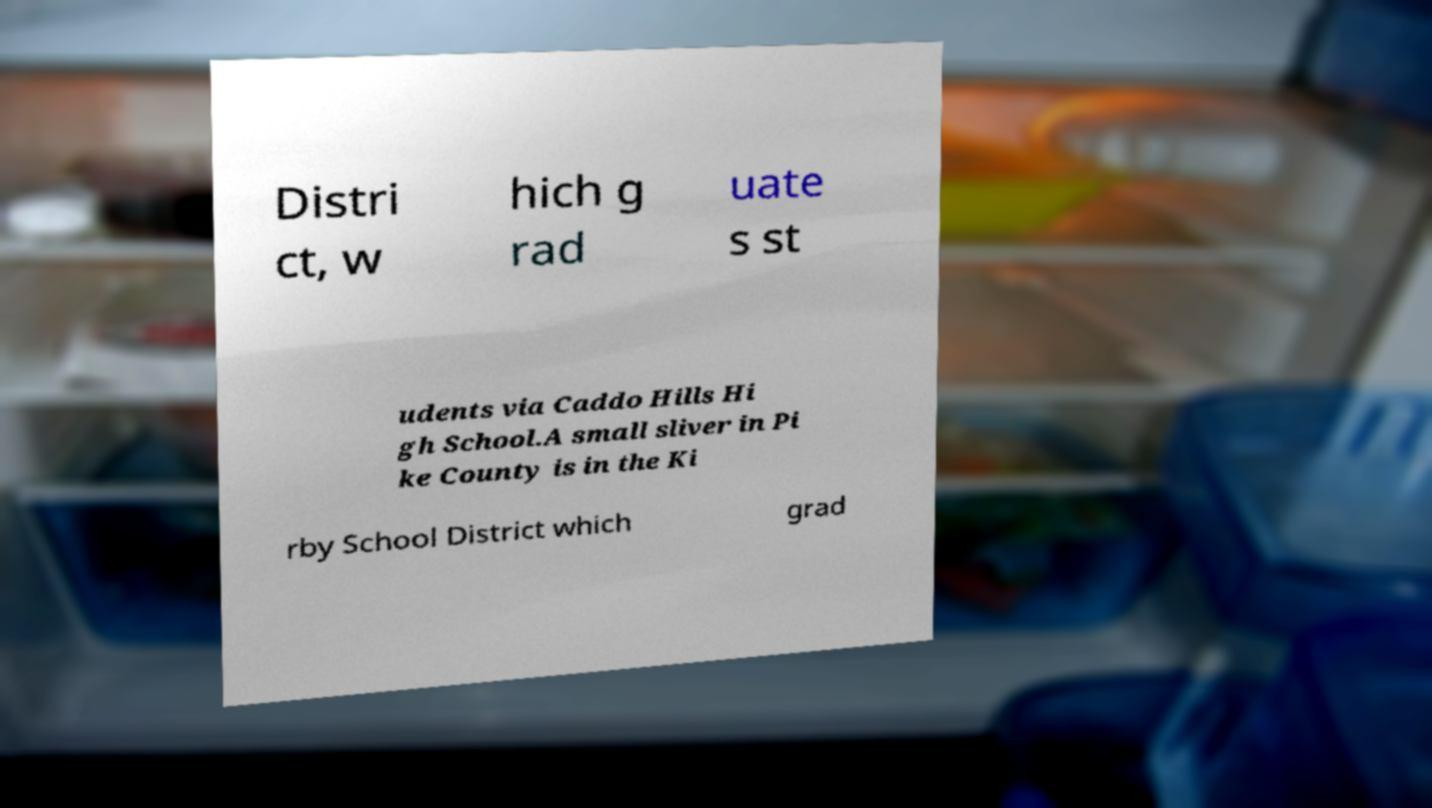Please read and relay the text visible in this image. What does it say? Distri ct, w hich g rad uate s st udents via Caddo Hills Hi gh School.A small sliver in Pi ke County is in the Ki rby School District which grad 